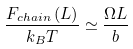<formula> <loc_0><loc_0><loc_500><loc_500>\frac { F _ { c h a i n } \left ( L \right ) } { k _ { B } T } \simeq \frac { \Omega L } { b }</formula> 